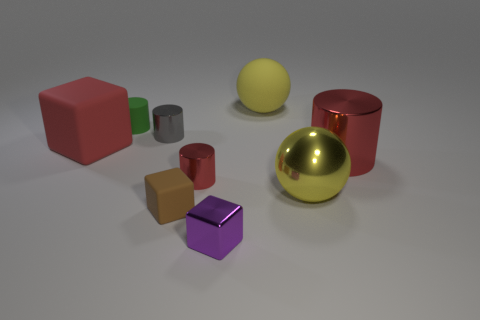Are there fewer brown objects that are behind the tiny gray object than rubber spheres that are behind the brown block?
Keep it short and to the point. Yes. How many other things are the same material as the gray thing?
Give a very brief answer. 4. What is the material of the red cylinder that is the same size as the gray metal thing?
Ensure brevity in your answer.  Metal. Are there fewer small purple metal blocks left of the big red matte block than brown matte blocks?
Provide a short and direct response. Yes. What is the shape of the rubber thing to the right of the red metallic cylinder that is left of the big yellow ball that is behind the yellow metal sphere?
Your answer should be compact. Sphere. There is a ball that is on the right side of the big yellow matte thing; what size is it?
Offer a terse response. Large. What shape is the metallic thing that is the same size as the yellow shiny ball?
Your answer should be very brief. Cylinder. What number of things are either cyan metal balls or cylinders behind the tiny gray metallic cylinder?
Provide a succinct answer. 1. How many tiny cubes are behind the large metal thing in front of the metal thing that is to the right of the shiny ball?
Keep it short and to the point. 0. There is a large cylinder that is the same material as the tiny purple thing; what color is it?
Your answer should be very brief. Red. 